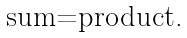Convert formula to latex. <formula><loc_0><loc_0><loc_500><loc_500>\text {sum=product.}</formula> 